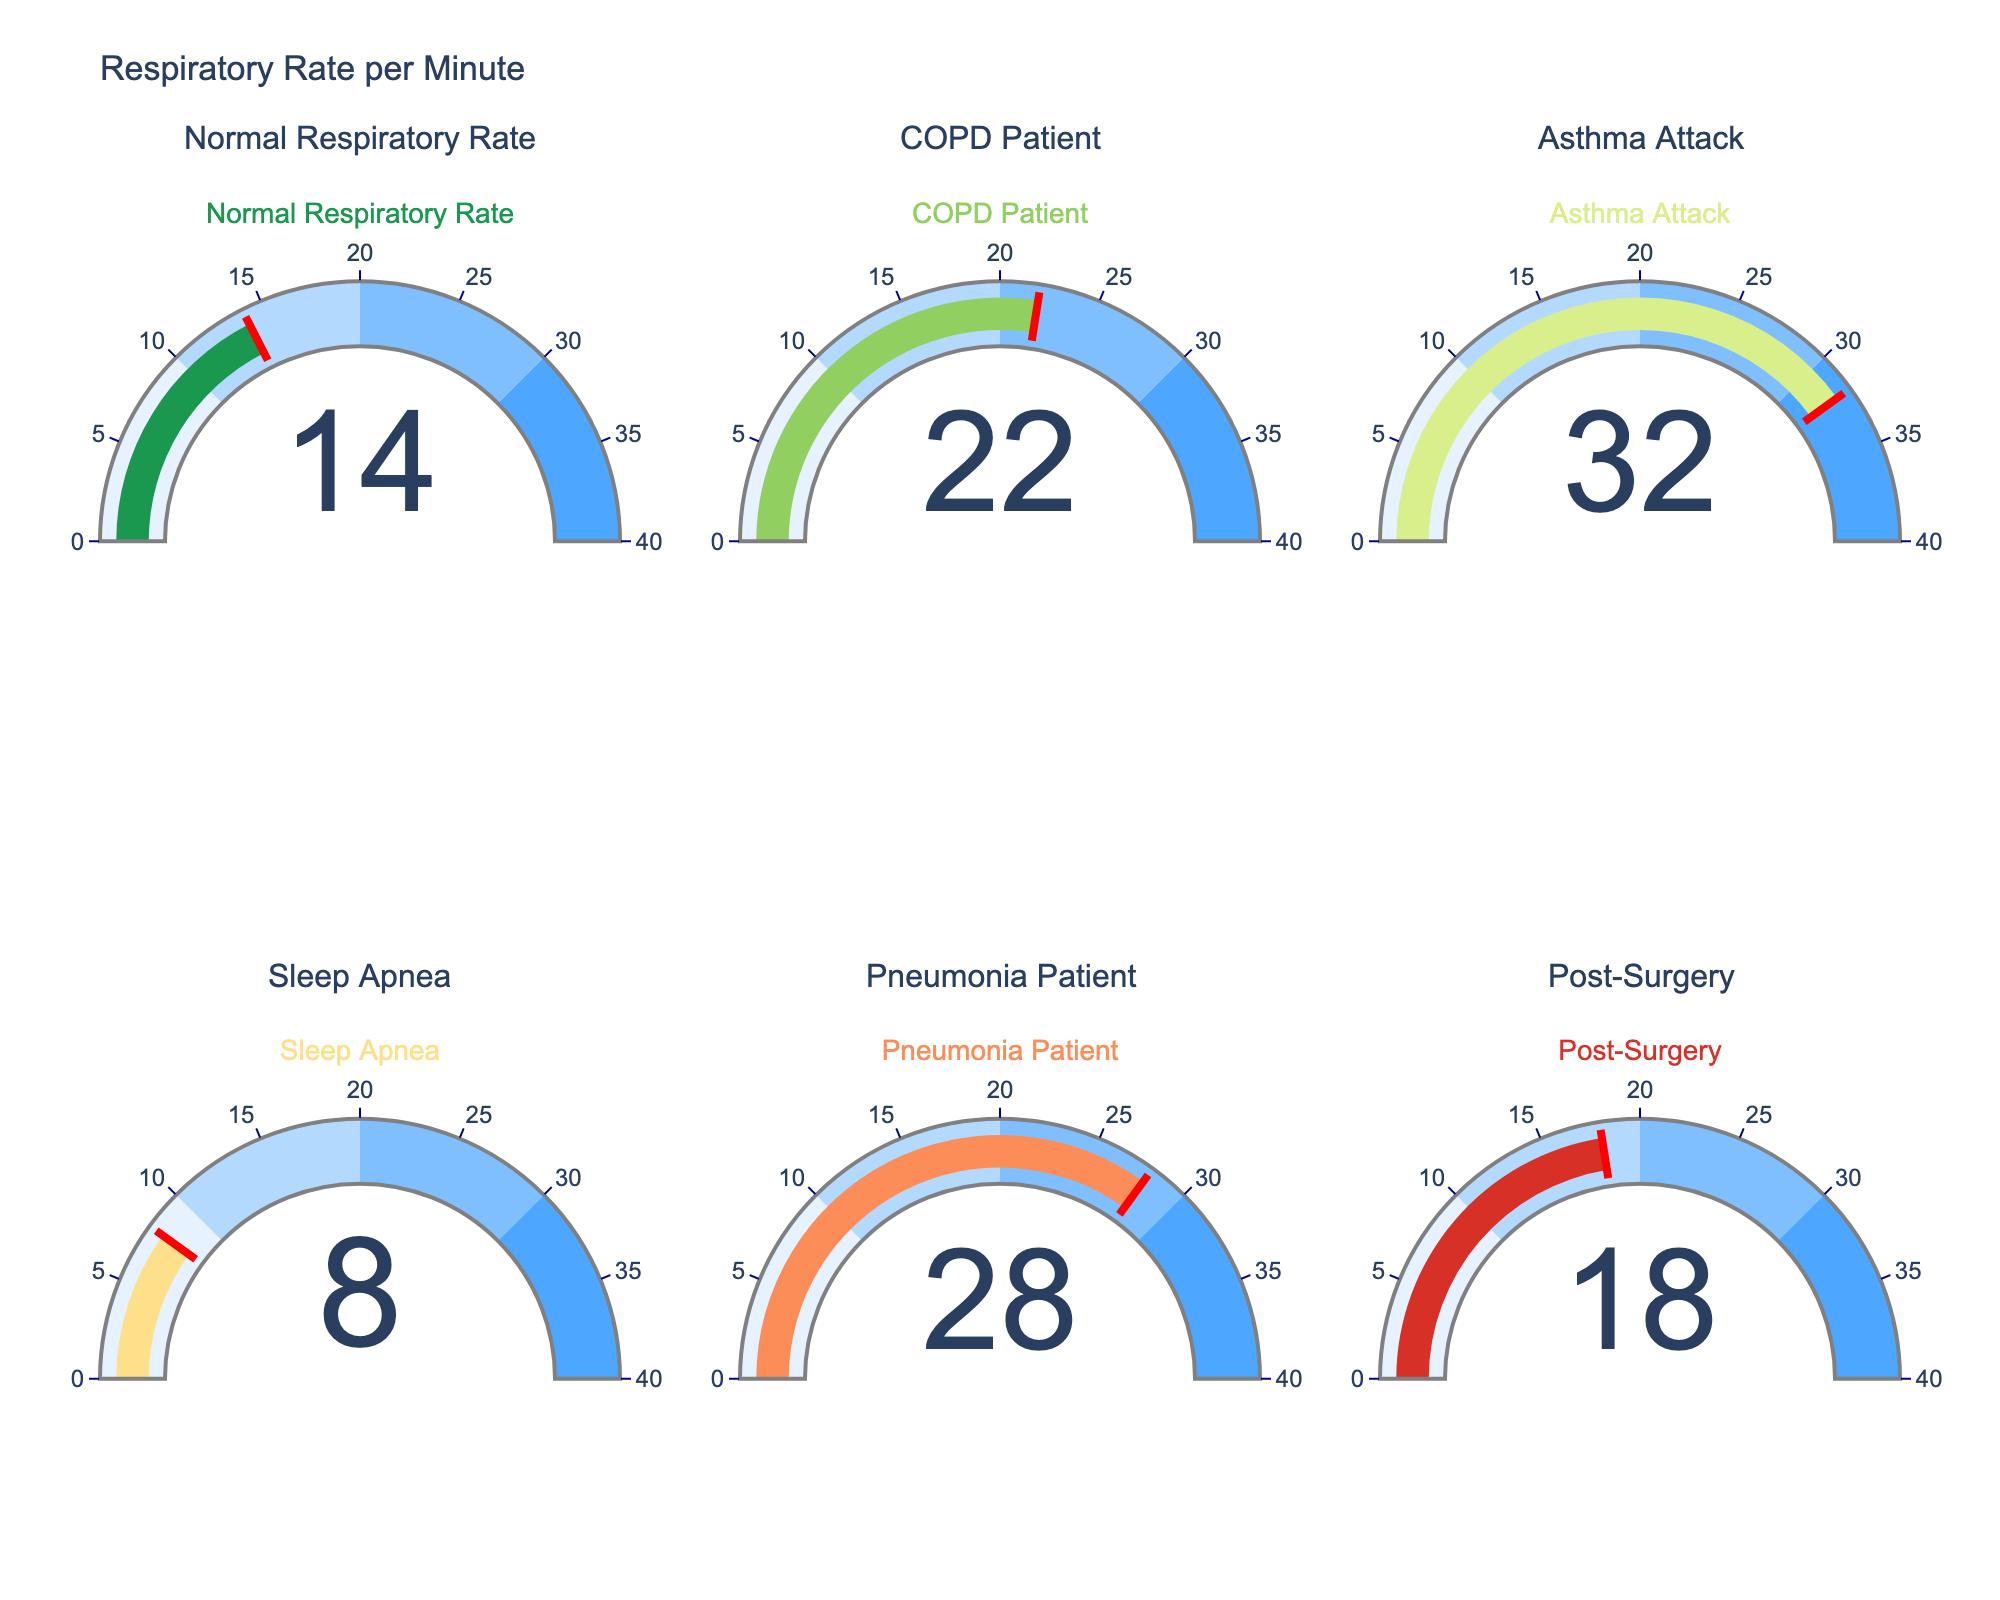What is the title of the figure? The title can be found at the top of the figure. It reads "Respiratory Rate per Minute".
Answer: Respiratory Rate per Minute Which condition has the highest respiratory rate? By looking at the gauges, the one with the highest value is the "Asthma Attack" gauge, which shows 32.
Answer: Asthma Attack How many respiratory rates are displayed in total? There are 6 gauges in total, each representing a different condition. You can count them in the subplots.
Answer: 6 What is the respiratory rate for a COPD patient? By looking at the gauge labeled "COPD Patient", you can see the number displayed is 22.
Answer: 22 How does the respiratory rate of a pneumonia patient compare to that of a post-surgery patient? The "Pneumonia Patient" gauge shows a value of 28, while the "Post-Surgery" gauge shows 18. Therefore, the pneumonia patient's respiratory rate is higher by 10.
Answer: Pneumonia patient has a higher rate by 10 What is the range of values shown on the respiratory rate gauges? By looking at the gauge axis, it ranges from 0 to 40.
Answer: 0 to 40 What is the average respiratory rate for the conditions displayed? Sum the values: 14 (Normal) + 22 (COPD) + 32 (Asthma) + 8 (Sleep Apnea) + 28 (Pneumonia) + 18 (Post-Surgery) = 122. There are 6 values, so the average is 122 / 6 = 20.33.
Answer: 20.33 Which condition has a respiratory rate below 10? The "Sleep Apnea" gauge shows a value of 8, which is below 10.
Answer: Sleep Apnea What’s the difference in respiratory rate between Sleep Apnea and Asthma Attack patients? The "Asthma Attack" gauge shows 32 and the "Sleep Apnea" gauge shows 8. The difference is 32 - 8 = 24.
Answer: 24 Are there any conditions that have a normal respiratory rate range (between 12 and 18)? By looking at the gauges, "Normal Respiratory Rate" has a value of 14, and "Post-Surgery" has a value of 18, both of which are within the normal range.
Answer: Yes, Normal Respiratory Rate and Post-Surgery 